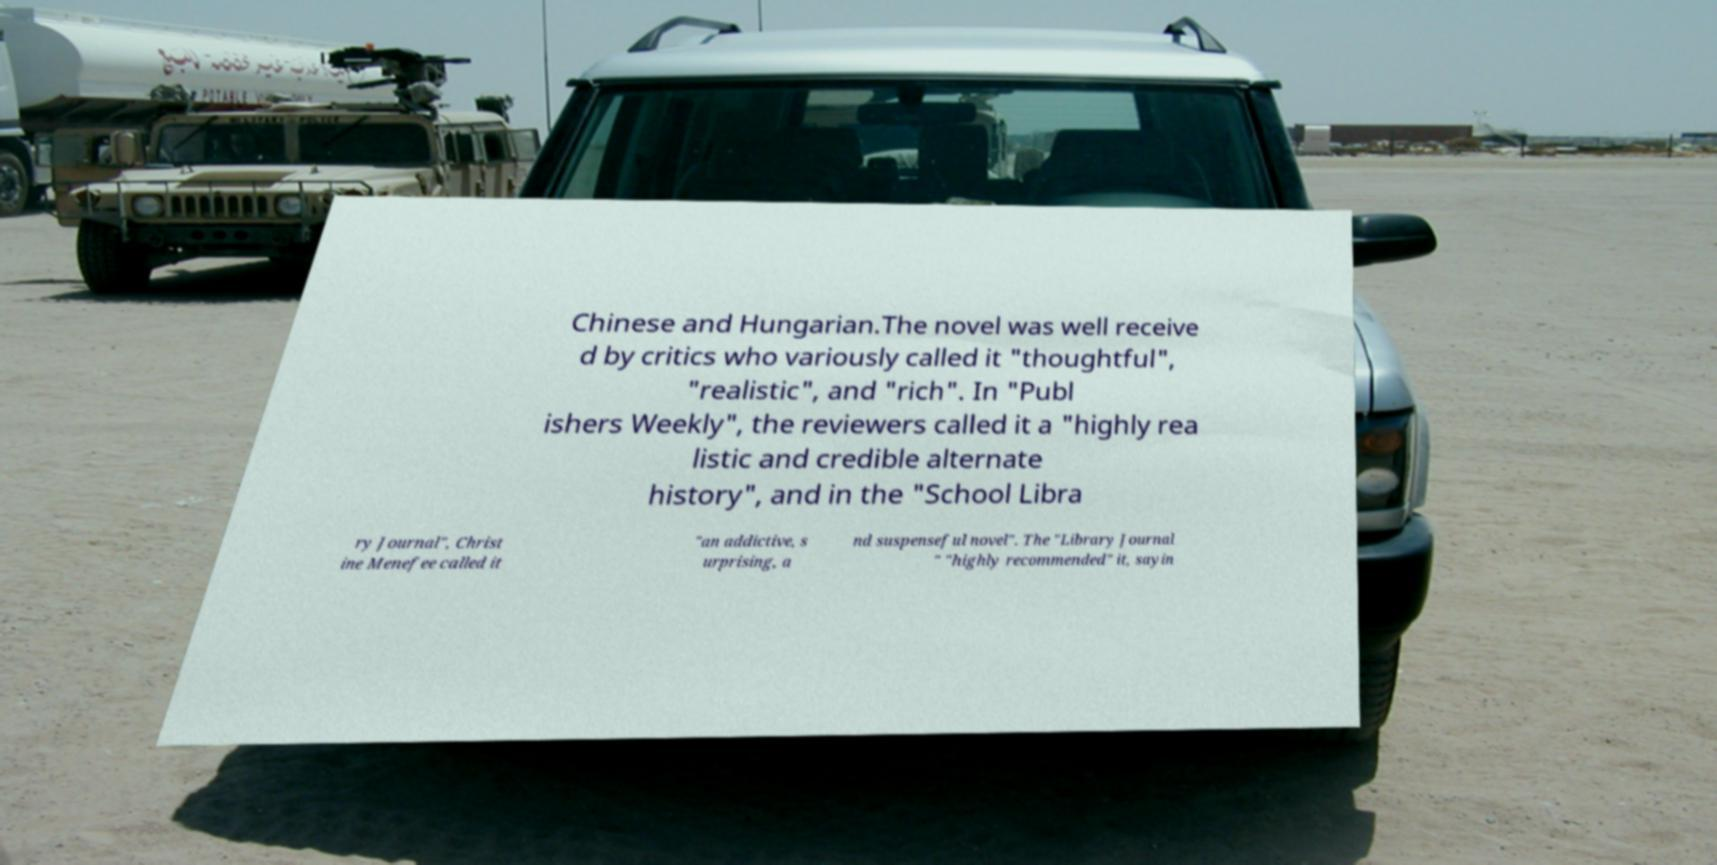I need the written content from this picture converted into text. Can you do that? Chinese and Hungarian.The novel was well receive d by critics who variously called it "thoughtful", "realistic", and "rich". In "Publ ishers Weekly", the reviewers called it a "highly rea listic and credible alternate history", and in the "School Libra ry Journal", Christ ine Menefee called it "an addictive, s urprising, a nd suspenseful novel". The "Library Journal " "highly recommended" it, sayin 